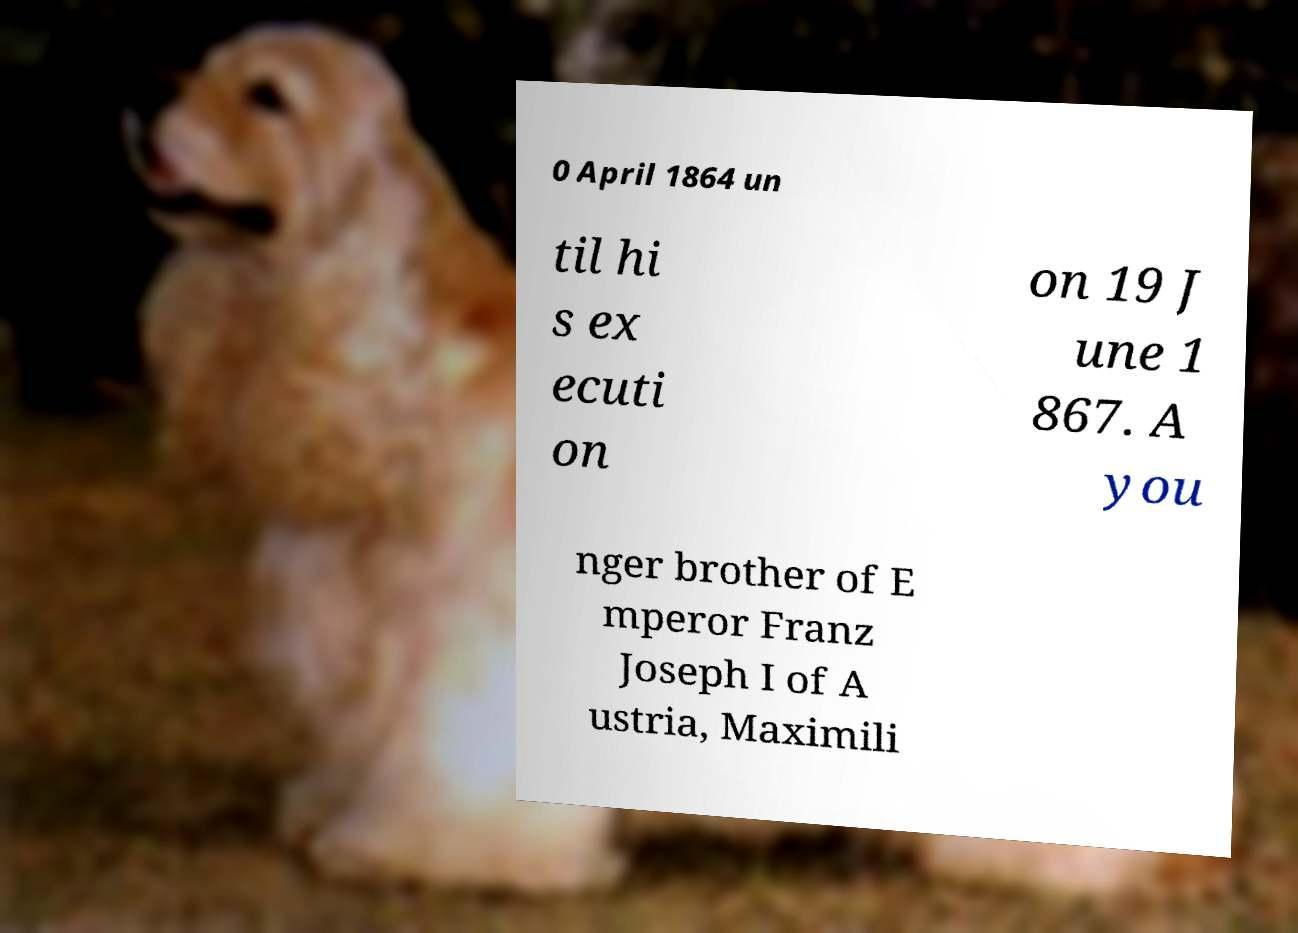Could you assist in decoding the text presented in this image and type it out clearly? 0 April 1864 un til hi s ex ecuti on on 19 J une 1 867. A you nger brother of E mperor Franz Joseph I of A ustria, Maximili 